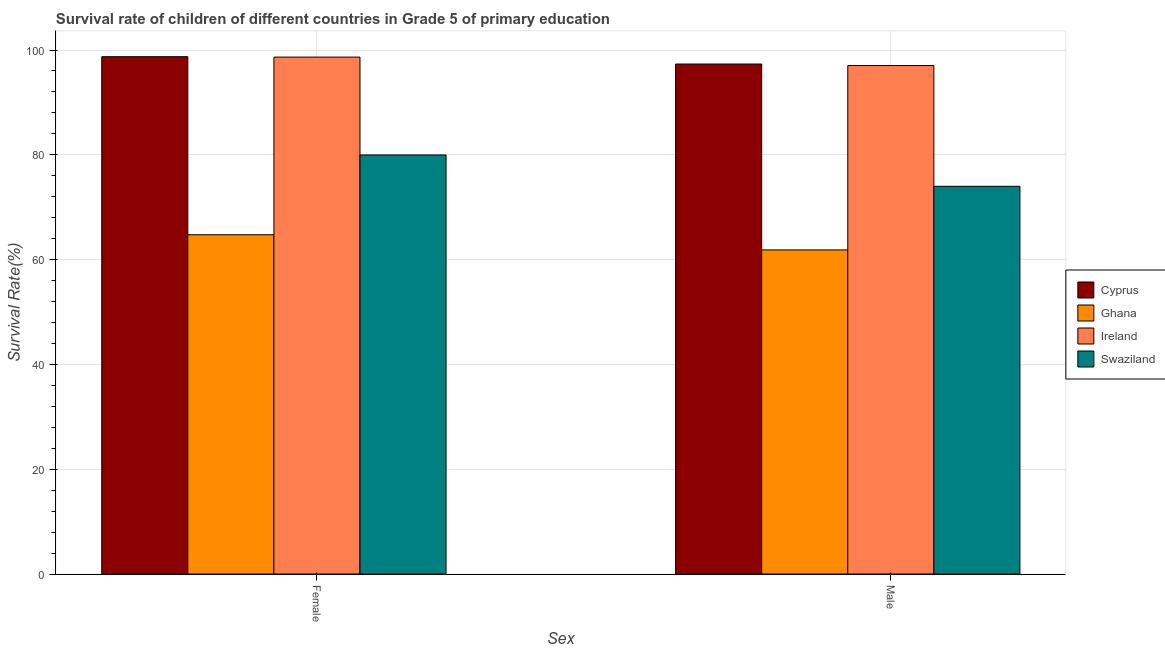Are the number of bars per tick equal to the number of legend labels?
Provide a succinct answer. Yes. What is the label of the 2nd group of bars from the left?
Your response must be concise. Male. What is the survival rate of female students in primary education in Cyprus?
Give a very brief answer. 98.72. Across all countries, what is the maximum survival rate of female students in primary education?
Make the answer very short. 98.72. Across all countries, what is the minimum survival rate of female students in primary education?
Offer a very short reply. 64.74. In which country was the survival rate of female students in primary education maximum?
Offer a very short reply. Cyprus. What is the total survival rate of female students in primary education in the graph?
Your answer should be compact. 342.08. What is the difference between the survival rate of female students in primary education in Cyprus and that in Ghana?
Your answer should be very brief. 33.98. What is the difference between the survival rate of male students in primary education in Swaziland and the survival rate of female students in primary education in Ghana?
Make the answer very short. 9.25. What is the average survival rate of male students in primary education per country?
Provide a short and direct response. 82.55. What is the difference between the survival rate of female students in primary education and survival rate of male students in primary education in Ghana?
Keep it short and to the point. 2.9. What is the ratio of the survival rate of female students in primary education in Cyprus to that in Ghana?
Give a very brief answer. 1.52. In how many countries, is the survival rate of male students in primary education greater than the average survival rate of male students in primary education taken over all countries?
Your answer should be very brief. 2. What does the 2nd bar from the left in Male represents?
Your answer should be very brief. Ghana. What does the 3rd bar from the right in Male represents?
Make the answer very short. Ghana. How many bars are there?
Make the answer very short. 8. Are all the bars in the graph horizontal?
Your answer should be very brief. No. How many countries are there in the graph?
Your answer should be compact. 4. What is the difference between two consecutive major ticks on the Y-axis?
Offer a terse response. 20. Does the graph contain any zero values?
Provide a short and direct response. No. Does the graph contain grids?
Your answer should be very brief. Yes. Where does the legend appear in the graph?
Keep it short and to the point. Center right. How are the legend labels stacked?
Give a very brief answer. Vertical. What is the title of the graph?
Give a very brief answer. Survival rate of children of different countries in Grade 5 of primary education. Does "Lebanon" appear as one of the legend labels in the graph?
Offer a very short reply. No. What is the label or title of the X-axis?
Ensure brevity in your answer.  Sex. What is the label or title of the Y-axis?
Give a very brief answer. Survival Rate(%). What is the Survival Rate(%) in Cyprus in Female?
Give a very brief answer. 98.72. What is the Survival Rate(%) of Ghana in Female?
Your response must be concise. 64.74. What is the Survival Rate(%) in Ireland in Female?
Make the answer very short. 98.65. What is the Survival Rate(%) of Swaziland in Female?
Your response must be concise. 79.97. What is the Survival Rate(%) of Cyprus in Male?
Provide a short and direct response. 97.32. What is the Survival Rate(%) of Ghana in Male?
Provide a short and direct response. 61.85. What is the Survival Rate(%) in Ireland in Male?
Your response must be concise. 97.04. What is the Survival Rate(%) of Swaziland in Male?
Make the answer very short. 73.99. Across all Sex, what is the maximum Survival Rate(%) in Cyprus?
Offer a terse response. 98.72. Across all Sex, what is the maximum Survival Rate(%) in Ghana?
Provide a succinct answer. 64.74. Across all Sex, what is the maximum Survival Rate(%) in Ireland?
Give a very brief answer. 98.65. Across all Sex, what is the maximum Survival Rate(%) in Swaziland?
Keep it short and to the point. 79.97. Across all Sex, what is the minimum Survival Rate(%) in Cyprus?
Your response must be concise. 97.32. Across all Sex, what is the minimum Survival Rate(%) of Ghana?
Provide a short and direct response. 61.85. Across all Sex, what is the minimum Survival Rate(%) of Ireland?
Offer a very short reply. 97.04. Across all Sex, what is the minimum Survival Rate(%) in Swaziland?
Your response must be concise. 73.99. What is the total Survival Rate(%) of Cyprus in the graph?
Ensure brevity in your answer.  196.05. What is the total Survival Rate(%) in Ghana in the graph?
Offer a very short reply. 126.59. What is the total Survival Rate(%) in Ireland in the graph?
Your answer should be compact. 195.68. What is the total Survival Rate(%) in Swaziland in the graph?
Give a very brief answer. 153.96. What is the difference between the Survival Rate(%) in Cyprus in Female and that in Male?
Make the answer very short. 1.4. What is the difference between the Survival Rate(%) of Ghana in Female and that in Male?
Provide a succinct answer. 2.9. What is the difference between the Survival Rate(%) in Ireland in Female and that in Male?
Ensure brevity in your answer.  1.61. What is the difference between the Survival Rate(%) of Swaziland in Female and that in Male?
Keep it short and to the point. 5.98. What is the difference between the Survival Rate(%) of Cyprus in Female and the Survival Rate(%) of Ghana in Male?
Offer a very short reply. 36.88. What is the difference between the Survival Rate(%) of Cyprus in Female and the Survival Rate(%) of Ireland in Male?
Make the answer very short. 1.69. What is the difference between the Survival Rate(%) in Cyprus in Female and the Survival Rate(%) in Swaziland in Male?
Your answer should be very brief. 24.73. What is the difference between the Survival Rate(%) in Ghana in Female and the Survival Rate(%) in Ireland in Male?
Make the answer very short. -32.29. What is the difference between the Survival Rate(%) in Ghana in Female and the Survival Rate(%) in Swaziland in Male?
Make the answer very short. -9.25. What is the difference between the Survival Rate(%) of Ireland in Female and the Survival Rate(%) of Swaziland in Male?
Your response must be concise. 24.66. What is the average Survival Rate(%) of Cyprus per Sex?
Offer a terse response. 98.02. What is the average Survival Rate(%) of Ghana per Sex?
Provide a succinct answer. 63.3. What is the average Survival Rate(%) in Ireland per Sex?
Ensure brevity in your answer.  97.84. What is the average Survival Rate(%) in Swaziland per Sex?
Offer a very short reply. 76.98. What is the difference between the Survival Rate(%) of Cyprus and Survival Rate(%) of Ghana in Female?
Your response must be concise. 33.98. What is the difference between the Survival Rate(%) of Cyprus and Survival Rate(%) of Ireland in Female?
Keep it short and to the point. 0.08. What is the difference between the Survival Rate(%) of Cyprus and Survival Rate(%) of Swaziland in Female?
Give a very brief answer. 18.76. What is the difference between the Survival Rate(%) in Ghana and Survival Rate(%) in Ireland in Female?
Offer a terse response. -33.9. What is the difference between the Survival Rate(%) in Ghana and Survival Rate(%) in Swaziland in Female?
Make the answer very short. -15.23. What is the difference between the Survival Rate(%) of Ireland and Survival Rate(%) of Swaziland in Female?
Offer a very short reply. 18.68. What is the difference between the Survival Rate(%) of Cyprus and Survival Rate(%) of Ghana in Male?
Offer a very short reply. 35.47. What is the difference between the Survival Rate(%) of Cyprus and Survival Rate(%) of Ireland in Male?
Ensure brevity in your answer.  0.28. What is the difference between the Survival Rate(%) in Cyprus and Survival Rate(%) in Swaziland in Male?
Provide a succinct answer. 23.33. What is the difference between the Survival Rate(%) in Ghana and Survival Rate(%) in Ireland in Male?
Make the answer very short. -35.19. What is the difference between the Survival Rate(%) in Ghana and Survival Rate(%) in Swaziland in Male?
Your answer should be very brief. -12.14. What is the difference between the Survival Rate(%) in Ireland and Survival Rate(%) in Swaziland in Male?
Your answer should be very brief. 23.05. What is the ratio of the Survival Rate(%) in Cyprus in Female to that in Male?
Your answer should be compact. 1.01. What is the ratio of the Survival Rate(%) in Ghana in Female to that in Male?
Provide a short and direct response. 1.05. What is the ratio of the Survival Rate(%) of Ireland in Female to that in Male?
Provide a succinct answer. 1.02. What is the ratio of the Survival Rate(%) of Swaziland in Female to that in Male?
Your answer should be compact. 1.08. What is the difference between the highest and the second highest Survival Rate(%) of Cyprus?
Provide a succinct answer. 1.4. What is the difference between the highest and the second highest Survival Rate(%) of Ghana?
Ensure brevity in your answer.  2.9. What is the difference between the highest and the second highest Survival Rate(%) in Ireland?
Provide a short and direct response. 1.61. What is the difference between the highest and the second highest Survival Rate(%) of Swaziland?
Ensure brevity in your answer.  5.98. What is the difference between the highest and the lowest Survival Rate(%) of Cyprus?
Keep it short and to the point. 1.4. What is the difference between the highest and the lowest Survival Rate(%) in Ghana?
Your answer should be compact. 2.9. What is the difference between the highest and the lowest Survival Rate(%) of Ireland?
Your response must be concise. 1.61. What is the difference between the highest and the lowest Survival Rate(%) of Swaziland?
Your answer should be compact. 5.98. 